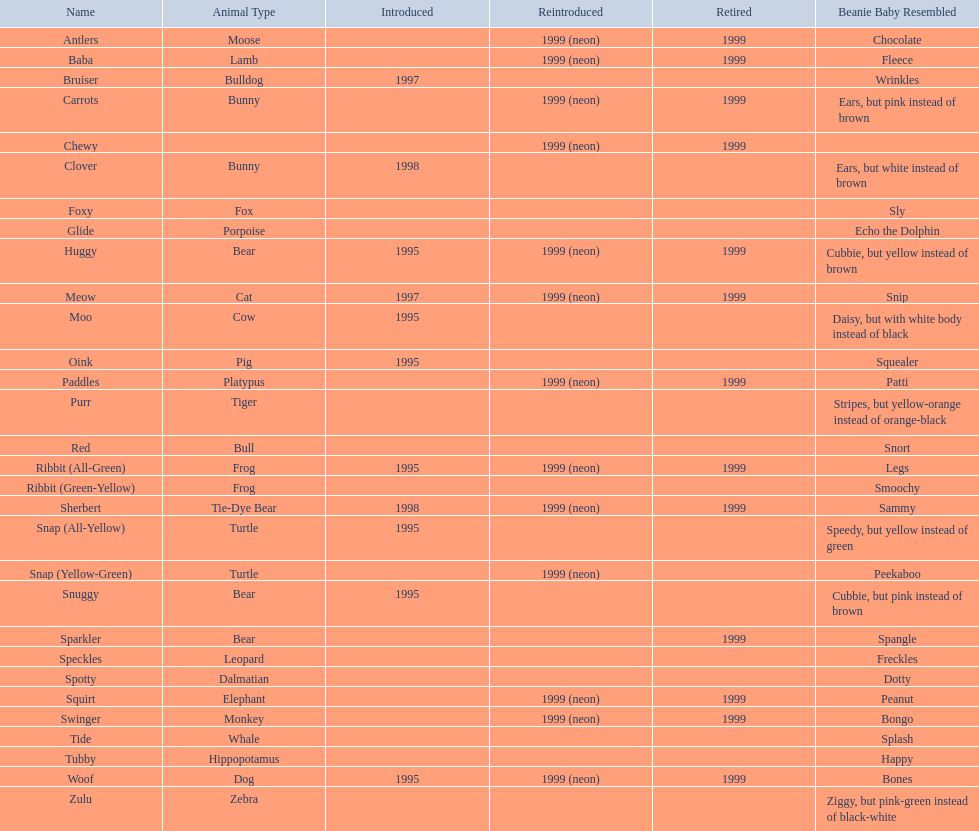Write the full table. {'header': ['Name', 'Animal Type', 'Introduced', 'Reintroduced', 'Retired', 'Beanie Baby Resembled'], 'rows': [['Antlers', 'Moose', '', '1999 (neon)', '1999', 'Chocolate'], ['Baba', 'Lamb', '', '1999 (neon)', '1999', 'Fleece'], ['Bruiser', 'Bulldog', '1997', '', '', 'Wrinkles'], ['Carrots', 'Bunny', '', '1999 (neon)', '1999', 'Ears, but pink instead of brown'], ['Chewy', '', '', '1999 (neon)', '1999', ''], ['Clover', 'Bunny', '1998', '', '', 'Ears, but white instead of brown'], ['Foxy', 'Fox', '', '', '', 'Sly'], ['Glide', 'Porpoise', '', '', '', 'Echo the Dolphin'], ['Huggy', 'Bear', '1995', '1999 (neon)', '1999', 'Cubbie, but yellow instead of brown'], ['Meow', 'Cat', '1997', '1999 (neon)', '1999', 'Snip'], ['Moo', 'Cow', '1995', '', '', 'Daisy, but with white body instead of black'], ['Oink', 'Pig', '1995', '', '', 'Squealer'], ['Paddles', 'Platypus', '', '1999 (neon)', '1999', 'Patti'], ['Purr', 'Tiger', '', '', '', 'Stripes, but yellow-orange instead of orange-black'], ['Red', 'Bull', '', '', '', 'Snort'], ['Ribbit (All-Green)', 'Frog', '1995', '1999 (neon)', '1999', 'Legs'], ['Ribbit (Green-Yellow)', 'Frog', '', '', '', 'Smoochy'], ['Sherbert', 'Tie-Dye Bear', '1998', '1999 (neon)', '1999', 'Sammy'], ['Snap (All-Yellow)', 'Turtle', '1995', '', '', 'Speedy, but yellow instead of green'], ['Snap (Yellow-Green)', 'Turtle', '', '1999 (neon)', '', 'Peekaboo'], ['Snuggy', 'Bear', '1995', '', '', 'Cubbie, but pink instead of brown'], ['Sparkler', 'Bear', '', '', '1999', 'Spangle'], ['Speckles', 'Leopard', '', '', '', 'Freckles'], ['Spotty', 'Dalmatian', '', '', '', 'Dotty'], ['Squirt', 'Elephant', '', '1999 (neon)', '1999', 'Peanut'], ['Swinger', 'Monkey', '', '1999 (neon)', '1999', 'Bongo'], ['Tide', 'Whale', '', '', '', 'Splash'], ['Tubby', 'Hippopotamus', '', '', '', 'Happy'], ['Woof', 'Dog', '1995', '1999 (neon)', '1999', 'Bones'], ['Zulu', 'Zebra', '', '', '', 'Ziggy, but pink-green instead of black-white']]} Identify the unique pillow pal that resembles a dalmatian. Spotty. 